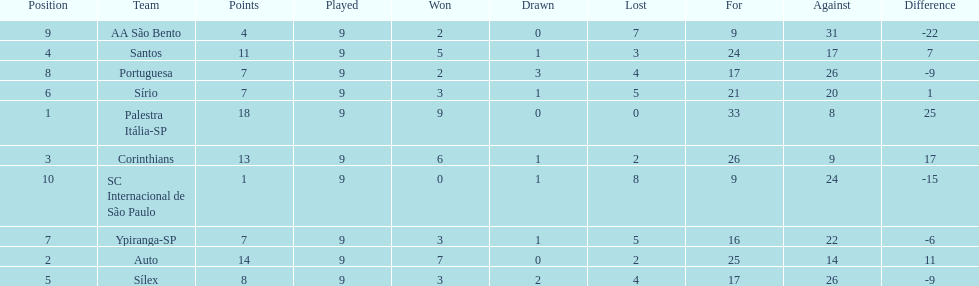Give me the full table as a dictionary. {'header': ['Position', 'Team', 'Points', 'Played', 'Won', 'Drawn', 'Lost', 'For', 'Against', 'Difference'], 'rows': [['9', 'AA São Bento', '4', '9', '2', '0', '7', '9', '31', '-22'], ['4', 'Santos', '11', '9', '5', '1', '3', '24', '17', '7'], ['8', 'Portuguesa', '7', '9', '2', '3', '4', '17', '26', '-9'], ['6', 'Sírio', '7', '9', '3', '1', '5', '21', '20', '1'], ['1', 'Palestra Itália-SP', '18', '9', '9', '0', '0', '33', '8', '25'], ['3', 'Corinthians', '13', '9', '6', '1', '2', '26', '9', '17'], ['10', 'SC Internacional de São Paulo', '1', '9', '0', '1', '8', '9', '24', '-15'], ['7', 'Ypiranga-SP', '7', '9', '3', '1', '5', '16', '22', '-6'], ['2', 'Auto', '14', '9', '7', '0', '2', '25', '14', '11'], ['5', 'Sílex', '8', '9', '3', '2', '4', '17', '26', '-9']]} How many points did the brazilian football team auto get in 1926? 14. 